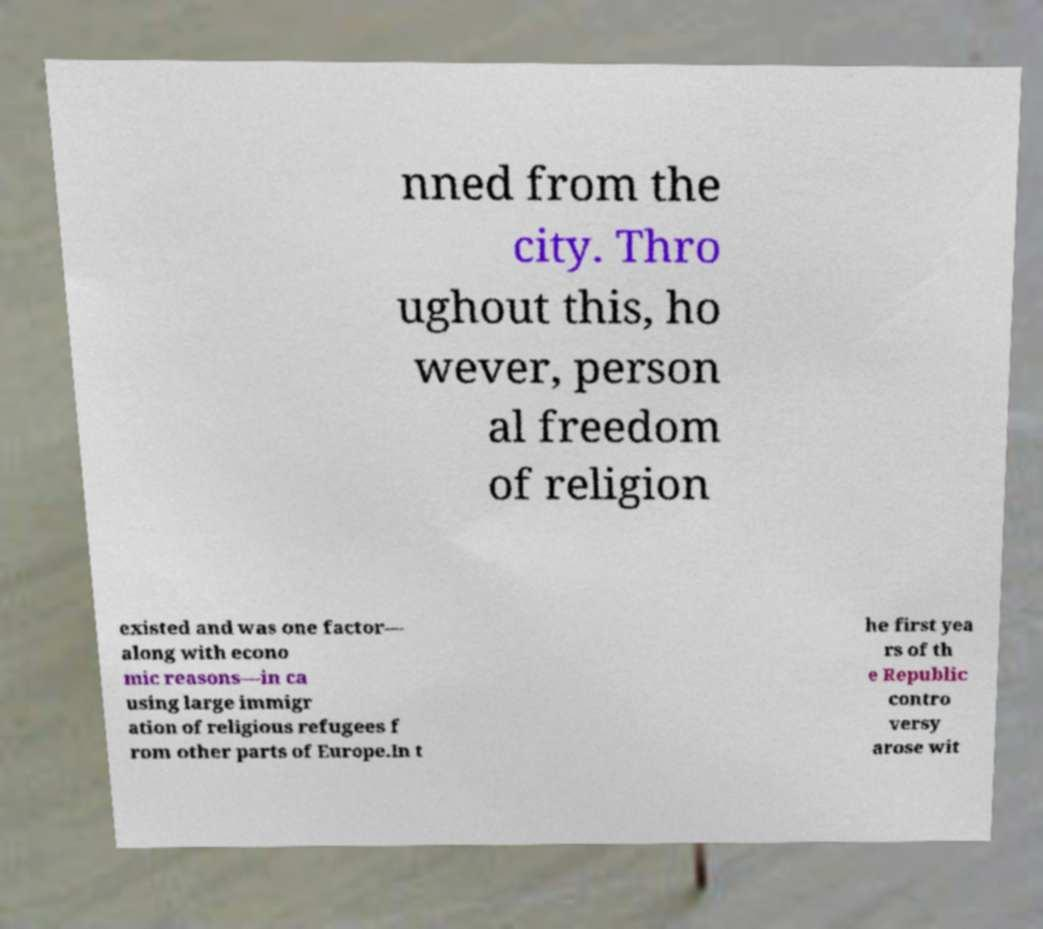Can you read and provide the text displayed in the image?This photo seems to have some interesting text. Can you extract and type it out for me? nned from the city. Thro ughout this, ho wever, person al freedom of religion existed and was one factor— along with econo mic reasons—in ca using large immigr ation of religious refugees f rom other parts of Europe.In t he first yea rs of th e Republic contro versy arose wit 